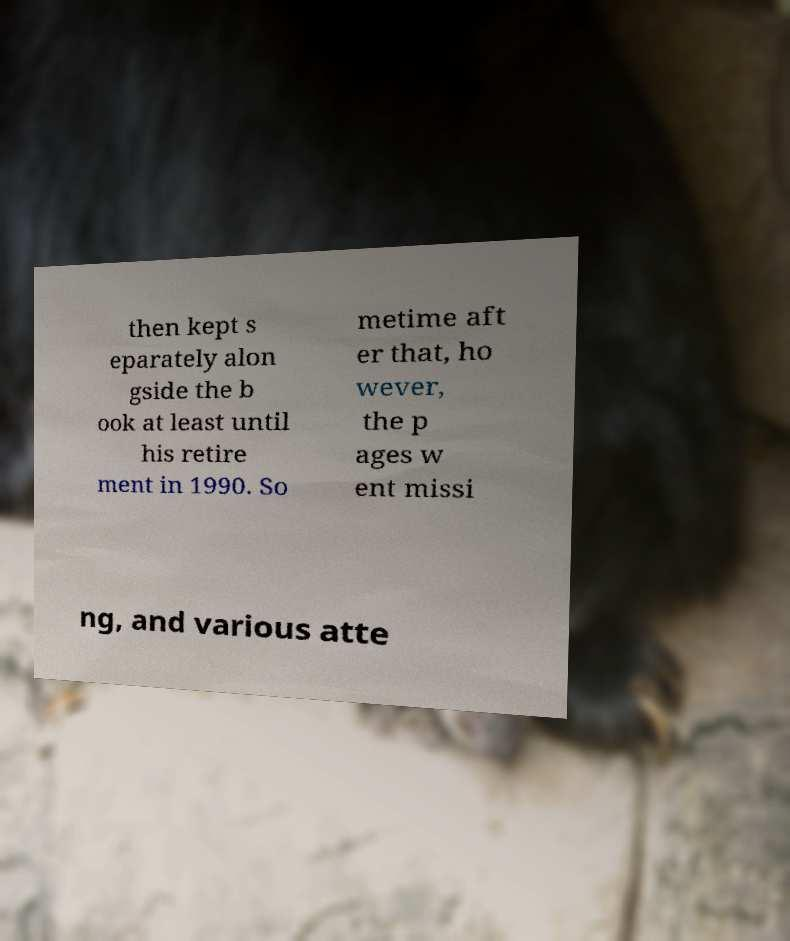Can you accurately transcribe the text from the provided image for me? then kept s eparately alon gside the b ook at least until his retire ment in 1990. So metime aft er that, ho wever, the p ages w ent missi ng, and various atte 